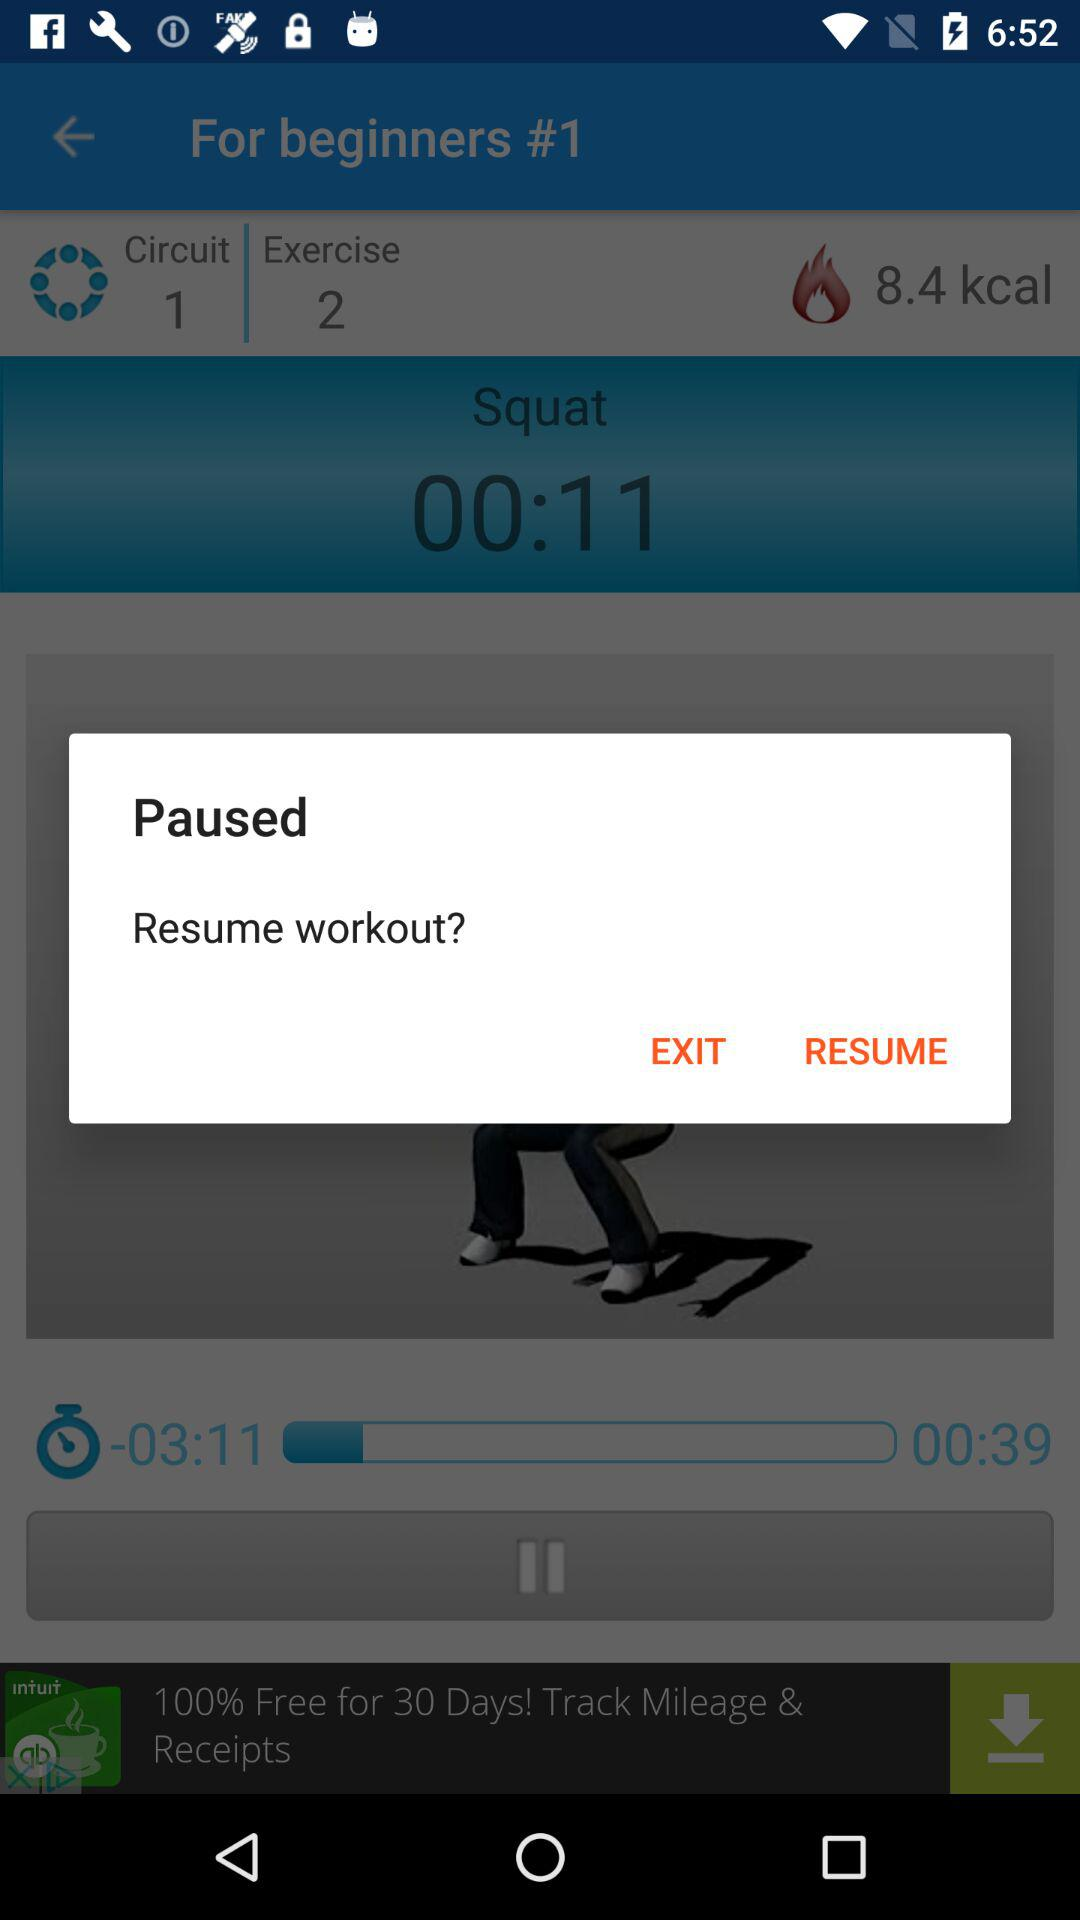How many people like it? There were 231,541 people who liked it. 